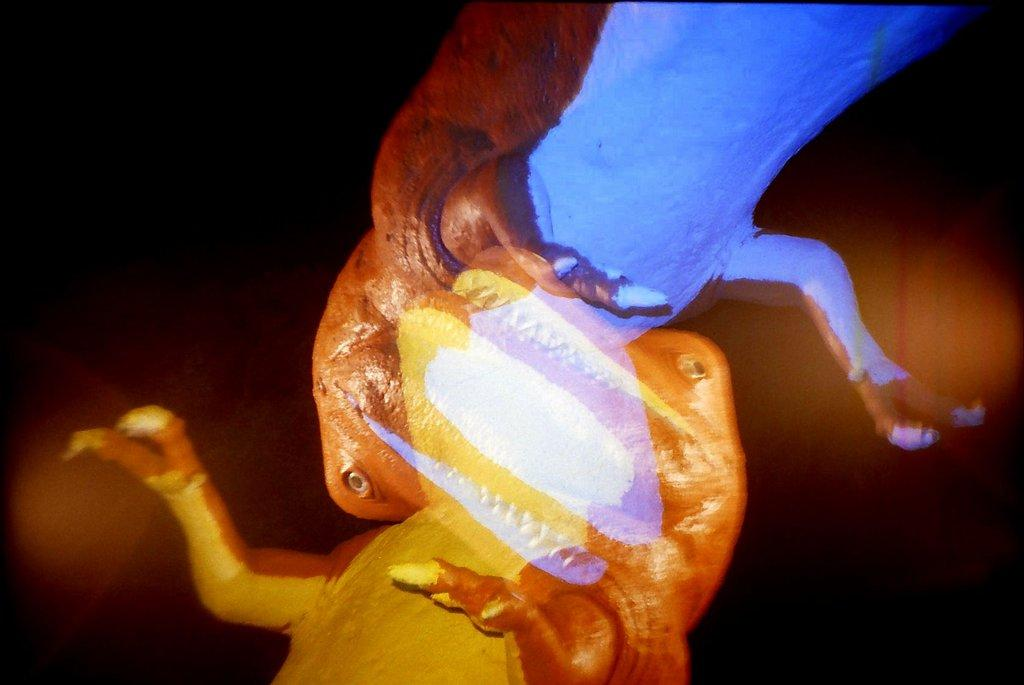How many animals are present in the image? There are two animals in the image. What can be observed about the background of the image? The background of the image is black. What type of appliance can be seen falling in the image? There is no appliance present in the image, and nothing is falling. 